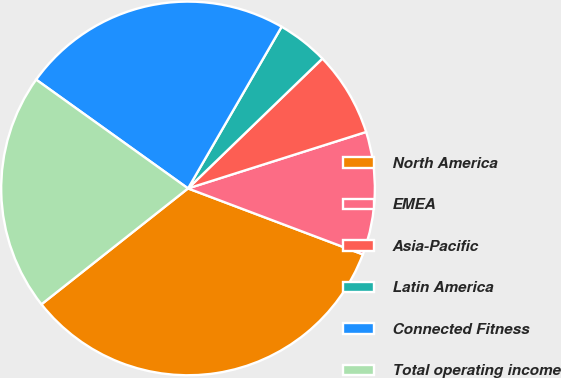Convert chart to OTSL. <chart><loc_0><loc_0><loc_500><loc_500><pie_chart><fcel>North America<fcel>EMEA<fcel>Asia-Pacific<fcel>Latin America<fcel>Connected Fitness<fcel>Total operating income<nl><fcel>33.61%<fcel>10.63%<fcel>7.34%<fcel>4.42%<fcel>23.46%<fcel>20.54%<nl></chart> 